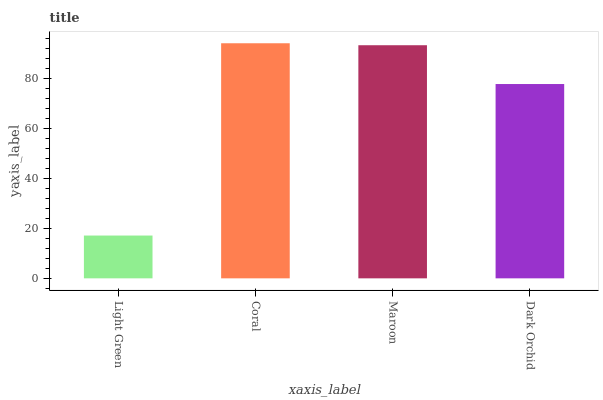Is Light Green the minimum?
Answer yes or no. Yes. Is Coral the maximum?
Answer yes or no. Yes. Is Maroon the minimum?
Answer yes or no. No. Is Maroon the maximum?
Answer yes or no. No. Is Coral greater than Maroon?
Answer yes or no. Yes. Is Maroon less than Coral?
Answer yes or no. Yes. Is Maroon greater than Coral?
Answer yes or no. No. Is Coral less than Maroon?
Answer yes or no. No. Is Maroon the high median?
Answer yes or no. Yes. Is Dark Orchid the low median?
Answer yes or no. Yes. Is Dark Orchid the high median?
Answer yes or no. No. Is Light Green the low median?
Answer yes or no. No. 